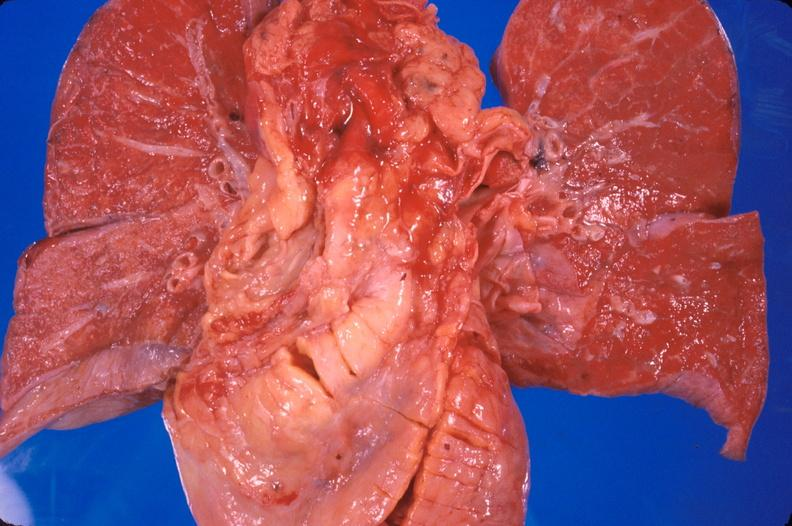what does this image show?
Answer the question using a single word or phrase. Heart transplant 